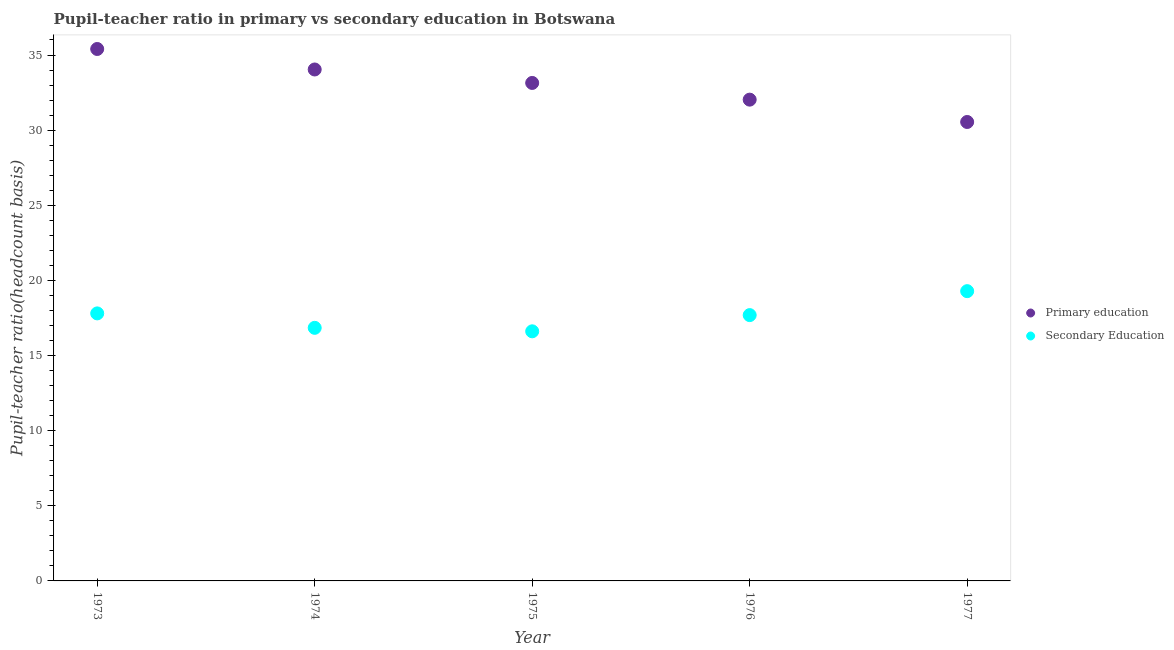How many different coloured dotlines are there?
Keep it short and to the point. 2. What is the pupil teacher ratio on secondary education in 1977?
Provide a short and direct response. 19.28. Across all years, what is the maximum pupil-teacher ratio in primary education?
Provide a succinct answer. 35.4. Across all years, what is the minimum pupil teacher ratio on secondary education?
Make the answer very short. 16.61. What is the total pupil teacher ratio on secondary education in the graph?
Provide a succinct answer. 88.23. What is the difference between the pupil-teacher ratio in primary education in 1974 and that in 1977?
Ensure brevity in your answer.  3.49. What is the difference between the pupil-teacher ratio in primary education in 1975 and the pupil teacher ratio on secondary education in 1977?
Ensure brevity in your answer.  13.86. What is the average pupil-teacher ratio in primary education per year?
Make the answer very short. 33.03. In the year 1976, what is the difference between the pupil-teacher ratio in primary education and pupil teacher ratio on secondary education?
Ensure brevity in your answer.  14.34. What is the ratio of the pupil-teacher ratio in primary education in 1975 to that in 1976?
Ensure brevity in your answer.  1.03. Is the pupil teacher ratio on secondary education in 1973 less than that in 1975?
Ensure brevity in your answer.  No. Is the difference between the pupil-teacher ratio in primary education in 1974 and 1976 greater than the difference between the pupil teacher ratio on secondary education in 1974 and 1976?
Provide a short and direct response. Yes. What is the difference between the highest and the second highest pupil-teacher ratio in primary education?
Ensure brevity in your answer.  1.36. What is the difference between the highest and the lowest pupil teacher ratio on secondary education?
Your response must be concise. 2.67. Does the pupil-teacher ratio in primary education monotonically increase over the years?
Give a very brief answer. No. Is the pupil-teacher ratio in primary education strictly greater than the pupil teacher ratio on secondary education over the years?
Provide a short and direct response. Yes. Is the pupil teacher ratio on secondary education strictly less than the pupil-teacher ratio in primary education over the years?
Make the answer very short. Yes. How many years are there in the graph?
Ensure brevity in your answer.  5. Are the values on the major ticks of Y-axis written in scientific E-notation?
Keep it short and to the point. No. What is the title of the graph?
Provide a short and direct response. Pupil-teacher ratio in primary vs secondary education in Botswana. Does "Stunting" appear as one of the legend labels in the graph?
Ensure brevity in your answer.  No. What is the label or title of the Y-axis?
Give a very brief answer. Pupil-teacher ratio(headcount basis). What is the Pupil-teacher ratio(headcount basis) in Primary education in 1973?
Provide a succinct answer. 35.4. What is the Pupil-teacher ratio(headcount basis) of Secondary Education in 1973?
Give a very brief answer. 17.8. What is the Pupil-teacher ratio(headcount basis) in Primary education in 1974?
Keep it short and to the point. 34.04. What is the Pupil-teacher ratio(headcount basis) of Secondary Education in 1974?
Your answer should be very brief. 16.84. What is the Pupil-teacher ratio(headcount basis) in Primary education in 1975?
Keep it short and to the point. 33.14. What is the Pupil-teacher ratio(headcount basis) in Secondary Education in 1975?
Offer a terse response. 16.61. What is the Pupil-teacher ratio(headcount basis) of Primary education in 1976?
Give a very brief answer. 32.03. What is the Pupil-teacher ratio(headcount basis) of Secondary Education in 1976?
Offer a terse response. 17.69. What is the Pupil-teacher ratio(headcount basis) in Primary education in 1977?
Your response must be concise. 30.54. What is the Pupil-teacher ratio(headcount basis) in Secondary Education in 1977?
Offer a terse response. 19.28. Across all years, what is the maximum Pupil-teacher ratio(headcount basis) of Primary education?
Keep it short and to the point. 35.4. Across all years, what is the maximum Pupil-teacher ratio(headcount basis) in Secondary Education?
Ensure brevity in your answer.  19.28. Across all years, what is the minimum Pupil-teacher ratio(headcount basis) in Primary education?
Give a very brief answer. 30.54. Across all years, what is the minimum Pupil-teacher ratio(headcount basis) of Secondary Education?
Offer a very short reply. 16.61. What is the total Pupil-teacher ratio(headcount basis) in Primary education in the graph?
Ensure brevity in your answer.  165.15. What is the total Pupil-teacher ratio(headcount basis) of Secondary Education in the graph?
Ensure brevity in your answer.  88.23. What is the difference between the Pupil-teacher ratio(headcount basis) of Primary education in 1973 and that in 1974?
Make the answer very short. 1.36. What is the difference between the Pupil-teacher ratio(headcount basis) in Secondary Education in 1973 and that in 1974?
Keep it short and to the point. 0.96. What is the difference between the Pupil-teacher ratio(headcount basis) in Primary education in 1973 and that in 1975?
Your response must be concise. 2.26. What is the difference between the Pupil-teacher ratio(headcount basis) in Secondary Education in 1973 and that in 1975?
Keep it short and to the point. 1.19. What is the difference between the Pupil-teacher ratio(headcount basis) of Primary education in 1973 and that in 1976?
Your answer should be compact. 3.37. What is the difference between the Pupil-teacher ratio(headcount basis) in Secondary Education in 1973 and that in 1976?
Give a very brief answer. 0.11. What is the difference between the Pupil-teacher ratio(headcount basis) in Primary education in 1973 and that in 1977?
Provide a succinct answer. 4.86. What is the difference between the Pupil-teacher ratio(headcount basis) in Secondary Education in 1973 and that in 1977?
Give a very brief answer. -1.48. What is the difference between the Pupil-teacher ratio(headcount basis) of Primary education in 1974 and that in 1975?
Offer a very short reply. 0.9. What is the difference between the Pupil-teacher ratio(headcount basis) of Secondary Education in 1974 and that in 1975?
Give a very brief answer. 0.23. What is the difference between the Pupil-teacher ratio(headcount basis) in Primary education in 1974 and that in 1976?
Offer a very short reply. 2.01. What is the difference between the Pupil-teacher ratio(headcount basis) of Secondary Education in 1974 and that in 1976?
Keep it short and to the point. -0.85. What is the difference between the Pupil-teacher ratio(headcount basis) of Primary education in 1974 and that in 1977?
Provide a short and direct response. 3.49. What is the difference between the Pupil-teacher ratio(headcount basis) in Secondary Education in 1974 and that in 1977?
Your response must be concise. -2.44. What is the difference between the Pupil-teacher ratio(headcount basis) in Primary education in 1975 and that in 1976?
Give a very brief answer. 1.11. What is the difference between the Pupil-teacher ratio(headcount basis) of Secondary Education in 1975 and that in 1976?
Offer a terse response. -1.08. What is the difference between the Pupil-teacher ratio(headcount basis) of Primary education in 1975 and that in 1977?
Your answer should be very brief. 2.6. What is the difference between the Pupil-teacher ratio(headcount basis) of Secondary Education in 1975 and that in 1977?
Offer a terse response. -2.67. What is the difference between the Pupil-teacher ratio(headcount basis) in Primary education in 1976 and that in 1977?
Your answer should be very brief. 1.49. What is the difference between the Pupil-teacher ratio(headcount basis) in Secondary Education in 1976 and that in 1977?
Provide a short and direct response. -1.59. What is the difference between the Pupil-teacher ratio(headcount basis) in Primary education in 1973 and the Pupil-teacher ratio(headcount basis) in Secondary Education in 1974?
Your response must be concise. 18.56. What is the difference between the Pupil-teacher ratio(headcount basis) in Primary education in 1973 and the Pupil-teacher ratio(headcount basis) in Secondary Education in 1975?
Provide a succinct answer. 18.79. What is the difference between the Pupil-teacher ratio(headcount basis) of Primary education in 1973 and the Pupil-teacher ratio(headcount basis) of Secondary Education in 1976?
Your answer should be compact. 17.71. What is the difference between the Pupil-teacher ratio(headcount basis) in Primary education in 1973 and the Pupil-teacher ratio(headcount basis) in Secondary Education in 1977?
Your response must be concise. 16.12. What is the difference between the Pupil-teacher ratio(headcount basis) of Primary education in 1974 and the Pupil-teacher ratio(headcount basis) of Secondary Education in 1975?
Offer a very short reply. 17.43. What is the difference between the Pupil-teacher ratio(headcount basis) of Primary education in 1974 and the Pupil-teacher ratio(headcount basis) of Secondary Education in 1976?
Make the answer very short. 16.35. What is the difference between the Pupil-teacher ratio(headcount basis) in Primary education in 1974 and the Pupil-teacher ratio(headcount basis) in Secondary Education in 1977?
Ensure brevity in your answer.  14.75. What is the difference between the Pupil-teacher ratio(headcount basis) of Primary education in 1975 and the Pupil-teacher ratio(headcount basis) of Secondary Education in 1976?
Offer a terse response. 15.45. What is the difference between the Pupil-teacher ratio(headcount basis) in Primary education in 1975 and the Pupil-teacher ratio(headcount basis) in Secondary Education in 1977?
Provide a succinct answer. 13.86. What is the difference between the Pupil-teacher ratio(headcount basis) in Primary education in 1976 and the Pupil-teacher ratio(headcount basis) in Secondary Education in 1977?
Provide a short and direct response. 12.75. What is the average Pupil-teacher ratio(headcount basis) in Primary education per year?
Make the answer very short. 33.03. What is the average Pupil-teacher ratio(headcount basis) in Secondary Education per year?
Ensure brevity in your answer.  17.65. In the year 1973, what is the difference between the Pupil-teacher ratio(headcount basis) in Primary education and Pupil-teacher ratio(headcount basis) in Secondary Education?
Your answer should be very brief. 17.6. In the year 1974, what is the difference between the Pupil-teacher ratio(headcount basis) in Primary education and Pupil-teacher ratio(headcount basis) in Secondary Education?
Keep it short and to the point. 17.19. In the year 1975, what is the difference between the Pupil-teacher ratio(headcount basis) of Primary education and Pupil-teacher ratio(headcount basis) of Secondary Education?
Offer a very short reply. 16.53. In the year 1976, what is the difference between the Pupil-teacher ratio(headcount basis) in Primary education and Pupil-teacher ratio(headcount basis) in Secondary Education?
Your response must be concise. 14.34. In the year 1977, what is the difference between the Pupil-teacher ratio(headcount basis) of Primary education and Pupil-teacher ratio(headcount basis) of Secondary Education?
Offer a terse response. 11.26. What is the ratio of the Pupil-teacher ratio(headcount basis) of Primary education in 1973 to that in 1974?
Keep it short and to the point. 1.04. What is the ratio of the Pupil-teacher ratio(headcount basis) in Secondary Education in 1973 to that in 1974?
Keep it short and to the point. 1.06. What is the ratio of the Pupil-teacher ratio(headcount basis) of Primary education in 1973 to that in 1975?
Give a very brief answer. 1.07. What is the ratio of the Pupil-teacher ratio(headcount basis) in Secondary Education in 1973 to that in 1975?
Your answer should be compact. 1.07. What is the ratio of the Pupil-teacher ratio(headcount basis) in Primary education in 1973 to that in 1976?
Provide a short and direct response. 1.11. What is the ratio of the Pupil-teacher ratio(headcount basis) of Secondary Education in 1973 to that in 1976?
Provide a short and direct response. 1.01. What is the ratio of the Pupil-teacher ratio(headcount basis) in Primary education in 1973 to that in 1977?
Provide a short and direct response. 1.16. What is the ratio of the Pupil-teacher ratio(headcount basis) in Secondary Education in 1973 to that in 1977?
Ensure brevity in your answer.  0.92. What is the ratio of the Pupil-teacher ratio(headcount basis) of Primary education in 1974 to that in 1975?
Give a very brief answer. 1.03. What is the ratio of the Pupil-teacher ratio(headcount basis) in Secondary Education in 1974 to that in 1975?
Your response must be concise. 1.01. What is the ratio of the Pupil-teacher ratio(headcount basis) of Primary education in 1974 to that in 1976?
Offer a terse response. 1.06. What is the ratio of the Pupil-teacher ratio(headcount basis) in Secondary Education in 1974 to that in 1976?
Your answer should be very brief. 0.95. What is the ratio of the Pupil-teacher ratio(headcount basis) of Primary education in 1974 to that in 1977?
Offer a very short reply. 1.11. What is the ratio of the Pupil-teacher ratio(headcount basis) of Secondary Education in 1974 to that in 1977?
Your answer should be very brief. 0.87. What is the ratio of the Pupil-teacher ratio(headcount basis) in Primary education in 1975 to that in 1976?
Ensure brevity in your answer.  1.03. What is the ratio of the Pupil-teacher ratio(headcount basis) of Secondary Education in 1975 to that in 1976?
Give a very brief answer. 0.94. What is the ratio of the Pupil-teacher ratio(headcount basis) of Primary education in 1975 to that in 1977?
Give a very brief answer. 1.09. What is the ratio of the Pupil-teacher ratio(headcount basis) of Secondary Education in 1975 to that in 1977?
Give a very brief answer. 0.86. What is the ratio of the Pupil-teacher ratio(headcount basis) of Primary education in 1976 to that in 1977?
Your answer should be compact. 1.05. What is the ratio of the Pupil-teacher ratio(headcount basis) in Secondary Education in 1976 to that in 1977?
Keep it short and to the point. 0.92. What is the difference between the highest and the second highest Pupil-teacher ratio(headcount basis) of Primary education?
Give a very brief answer. 1.36. What is the difference between the highest and the second highest Pupil-teacher ratio(headcount basis) in Secondary Education?
Give a very brief answer. 1.48. What is the difference between the highest and the lowest Pupil-teacher ratio(headcount basis) of Primary education?
Provide a short and direct response. 4.86. What is the difference between the highest and the lowest Pupil-teacher ratio(headcount basis) of Secondary Education?
Make the answer very short. 2.67. 